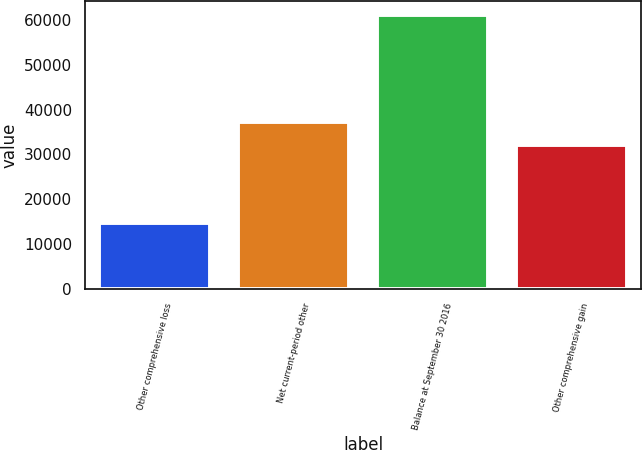Convert chart. <chart><loc_0><loc_0><loc_500><loc_500><bar_chart><fcel>Other comprehensive loss<fcel>Net current-period other<fcel>Balance at September 30 2016<fcel>Other comprehensive gain<nl><fcel>14797.2<fcel>37221.2<fcel>61140<fcel>32072<nl></chart> 